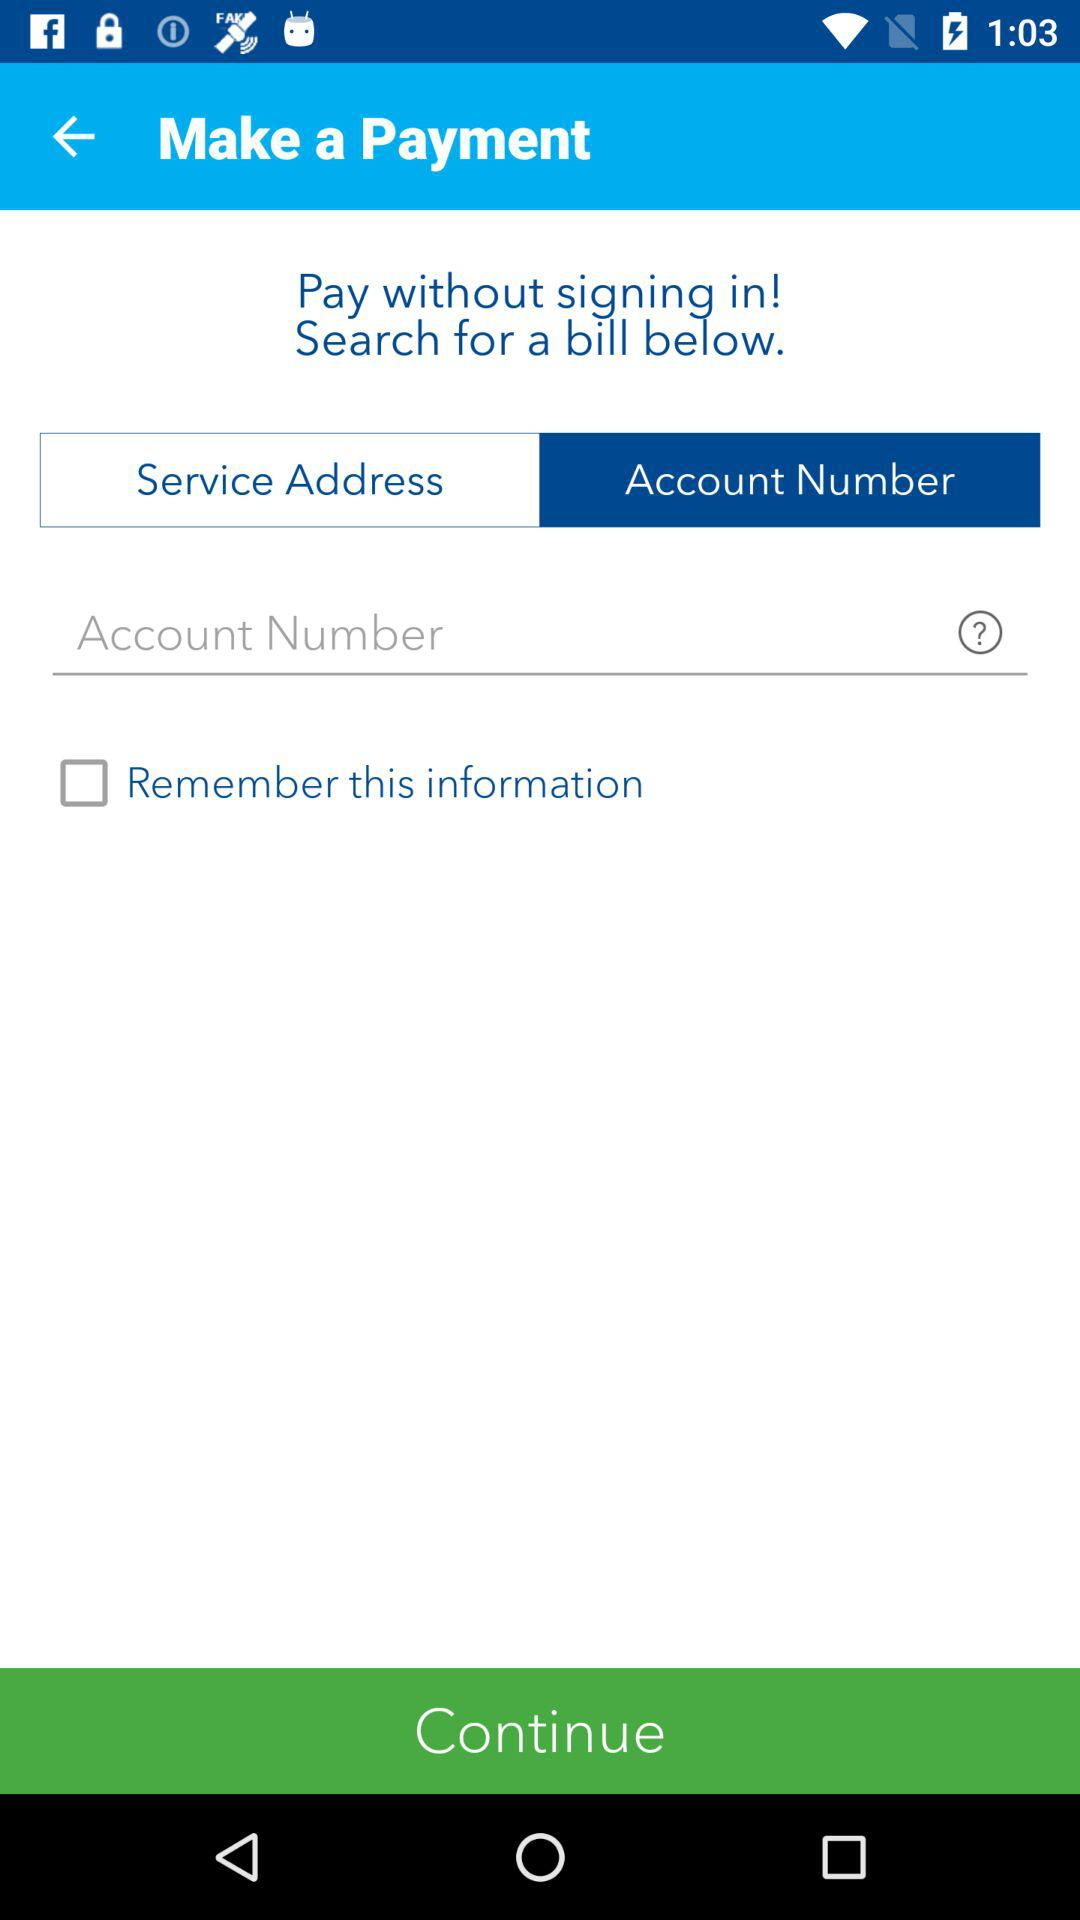What is the status of "Remember this information"? The status is "off". 